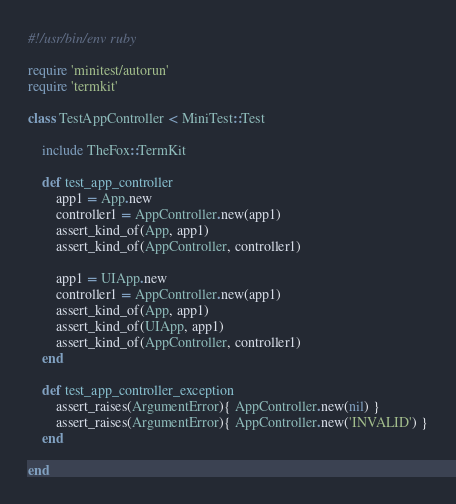Convert code to text. <code><loc_0><loc_0><loc_500><loc_500><_Ruby_>#!/usr/bin/env ruby

require 'minitest/autorun'
require 'termkit'

class TestAppController < MiniTest::Test
	
	include TheFox::TermKit
	
	def test_app_controller
		app1 = App.new
		controller1 = AppController.new(app1)
		assert_kind_of(App, app1)
		assert_kind_of(AppController, controller1)
		
		app1 = UIApp.new
		controller1 = AppController.new(app1)
		assert_kind_of(App, app1)
		assert_kind_of(UIApp, app1)
		assert_kind_of(AppController, controller1)
	end
	
	def test_app_controller_exception
		assert_raises(ArgumentError){ AppController.new(nil) }
		assert_raises(ArgumentError){ AppController.new('INVALID') }
	end
	
end
</code> 